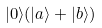<formula> <loc_0><loc_0><loc_500><loc_500>| 0 \rangle ( | a \rangle + | b \rangle )</formula> 